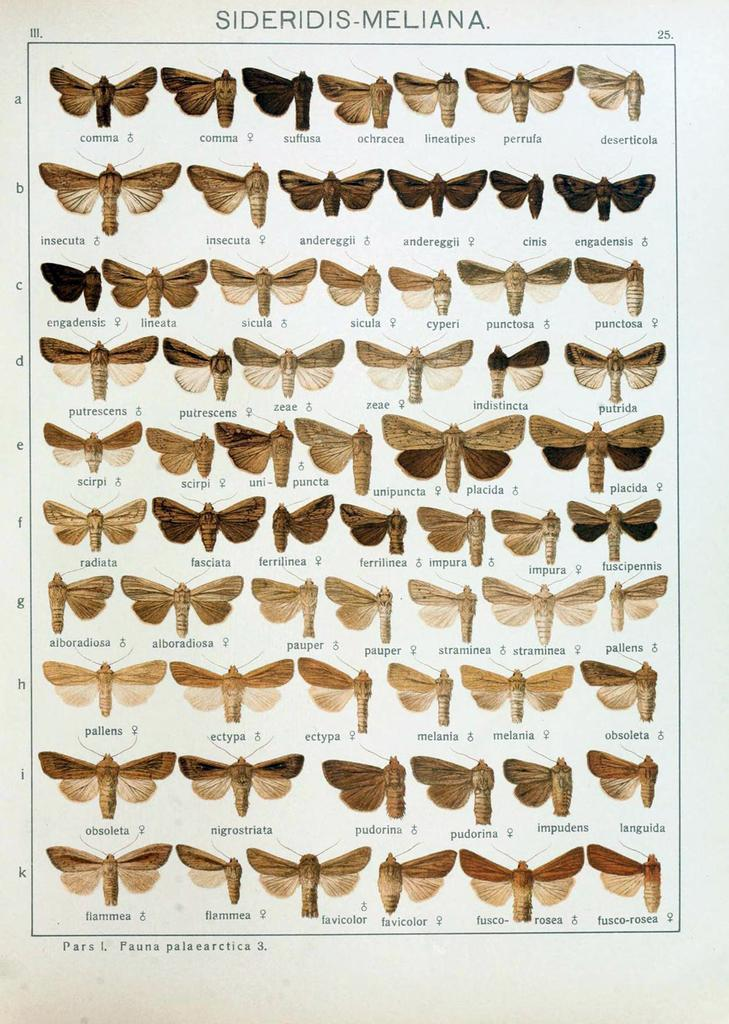What is depicted on the paper in the image? There are butterflies on the paper in the image. What type of hospital is visible in the image? There is no hospital present in the image; it features butterflies on a paper. What color is the robin's skirt in the image? There is no robin or skirt present in the image. 